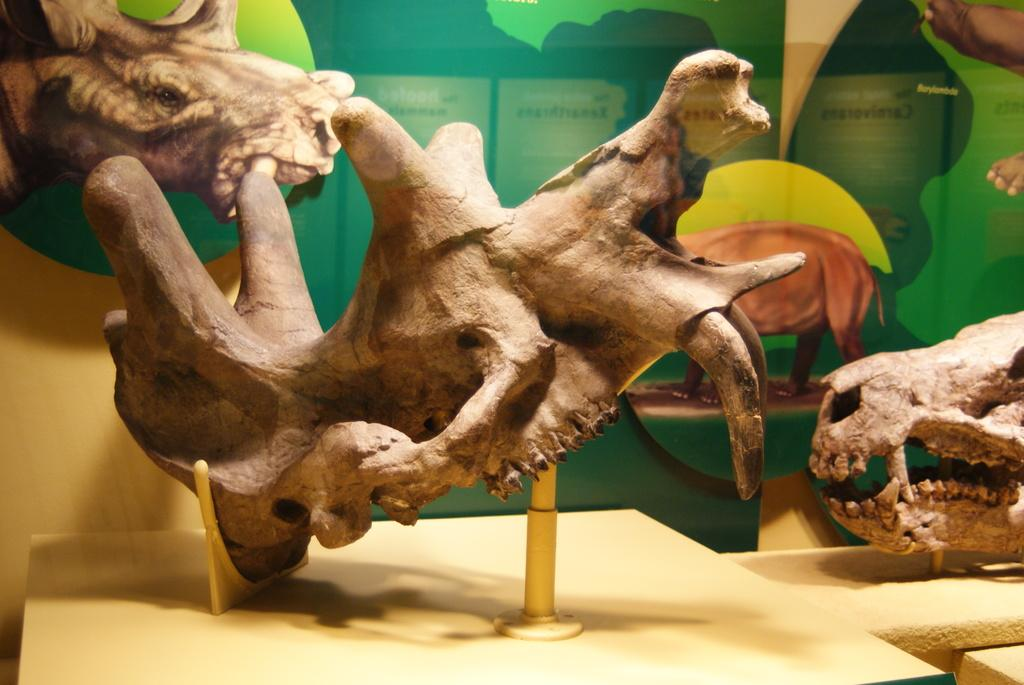What type of objects are featured in the image? There are skulls of animals in the image. How are the skulls displayed in the image? The skulls are placed on stands. Are there any additional details visible on the backside of the image? Yes, there are pictures and text on the backside of the image. What type of birds can be seen flying in the image? There are no birds visible in the image; it features skulls of animals placed on stands. 